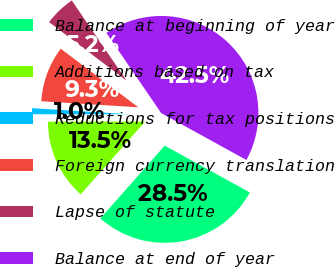Convert chart. <chart><loc_0><loc_0><loc_500><loc_500><pie_chart><fcel>Balance at beginning of year<fcel>Additions based on tax<fcel>Reductions for tax positions<fcel>Foreign currency translation<fcel>Lapse of statute<fcel>Balance at end of year<nl><fcel>28.53%<fcel>13.46%<fcel>1.0%<fcel>9.31%<fcel>5.16%<fcel>42.54%<nl></chart> 